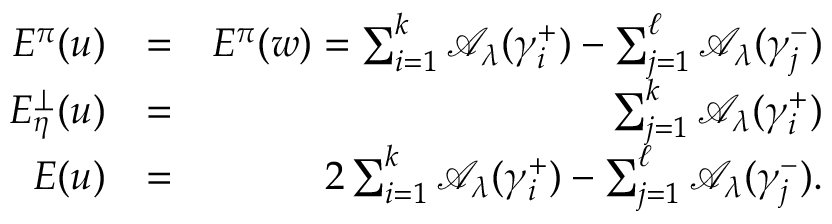<formula> <loc_0><loc_0><loc_500><loc_500>\begin{array} { r l r } { E ^ { \pi } ( u ) } & { = } & { E ^ { \pi } ( w ) = \sum _ { i = 1 } ^ { k } { \mathcal { A } } _ { \lambda } ( \gamma _ { i } ^ { + } ) - \sum _ { j = 1 } ^ { \ell } { \mathcal { A } } _ { \lambda } ( \gamma _ { j } ^ { - } ) } \\ { E _ { \eta } ^ { \perp } ( u ) } & { = } & { \sum _ { j = 1 } ^ { k } { \mathcal { A } } _ { \lambda } ( \gamma _ { i } ^ { + } ) } \\ { E ( u ) } & { = } & { 2 \sum _ { i = 1 } ^ { k } { \mathcal { A } } _ { \lambda } ( \gamma _ { i } ^ { + } ) - \sum _ { j = 1 } ^ { \ell } { \mathcal { A } } _ { \lambda } ( \gamma _ { j } ^ { - } ) . } \end{array}</formula> 